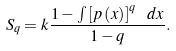<formula> <loc_0><loc_0><loc_500><loc_500>S _ { q } = k \frac { 1 - \int \left [ p \left ( x \right ) \right ] ^ { q } \ d x } { 1 - q } .</formula> 